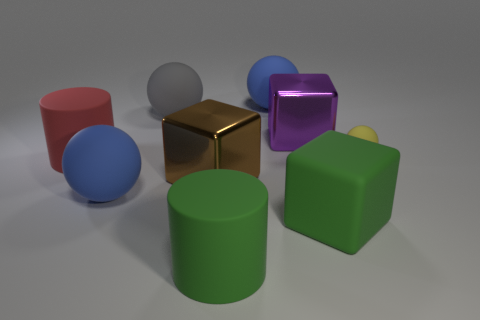There is a metallic thing to the left of the purple metallic cube; what is its color?
Make the answer very short. Brown. What number of balls are large gray things or big green matte things?
Keep it short and to the point. 1. There is a yellow thing to the right of the big cylinder behind the large rubber block; what size is it?
Provide a short and direct response. Small. Is the color of the large rubber cube the same as the matte cylinder that is in front of the brown metallic thing?
Your answer should be compact. Yes. There is a yellow sphere; how many blue things are in front of it?
Ensure brevity in your answer.  1. Are there fewer yellow spheres than tiny gray objects?
Ensure brevity in your answer.  No. There is a thing that is to the right of the purple thing and behind the red rubber thing; what size is it?
Keep it short and to the point. Small. There is a rubber cylinder that is on the right side of the large gray sphere; is its color the same as the rubber block?
Offer a terse response. Yes. Is the number of gray matte balls behind the big gray thing less than the number of large red metallic cylinders?
Your answer should be very brief. No. What shape is the large thing that is the same material as the big purple cube?
Make the answer very short. Cube. 